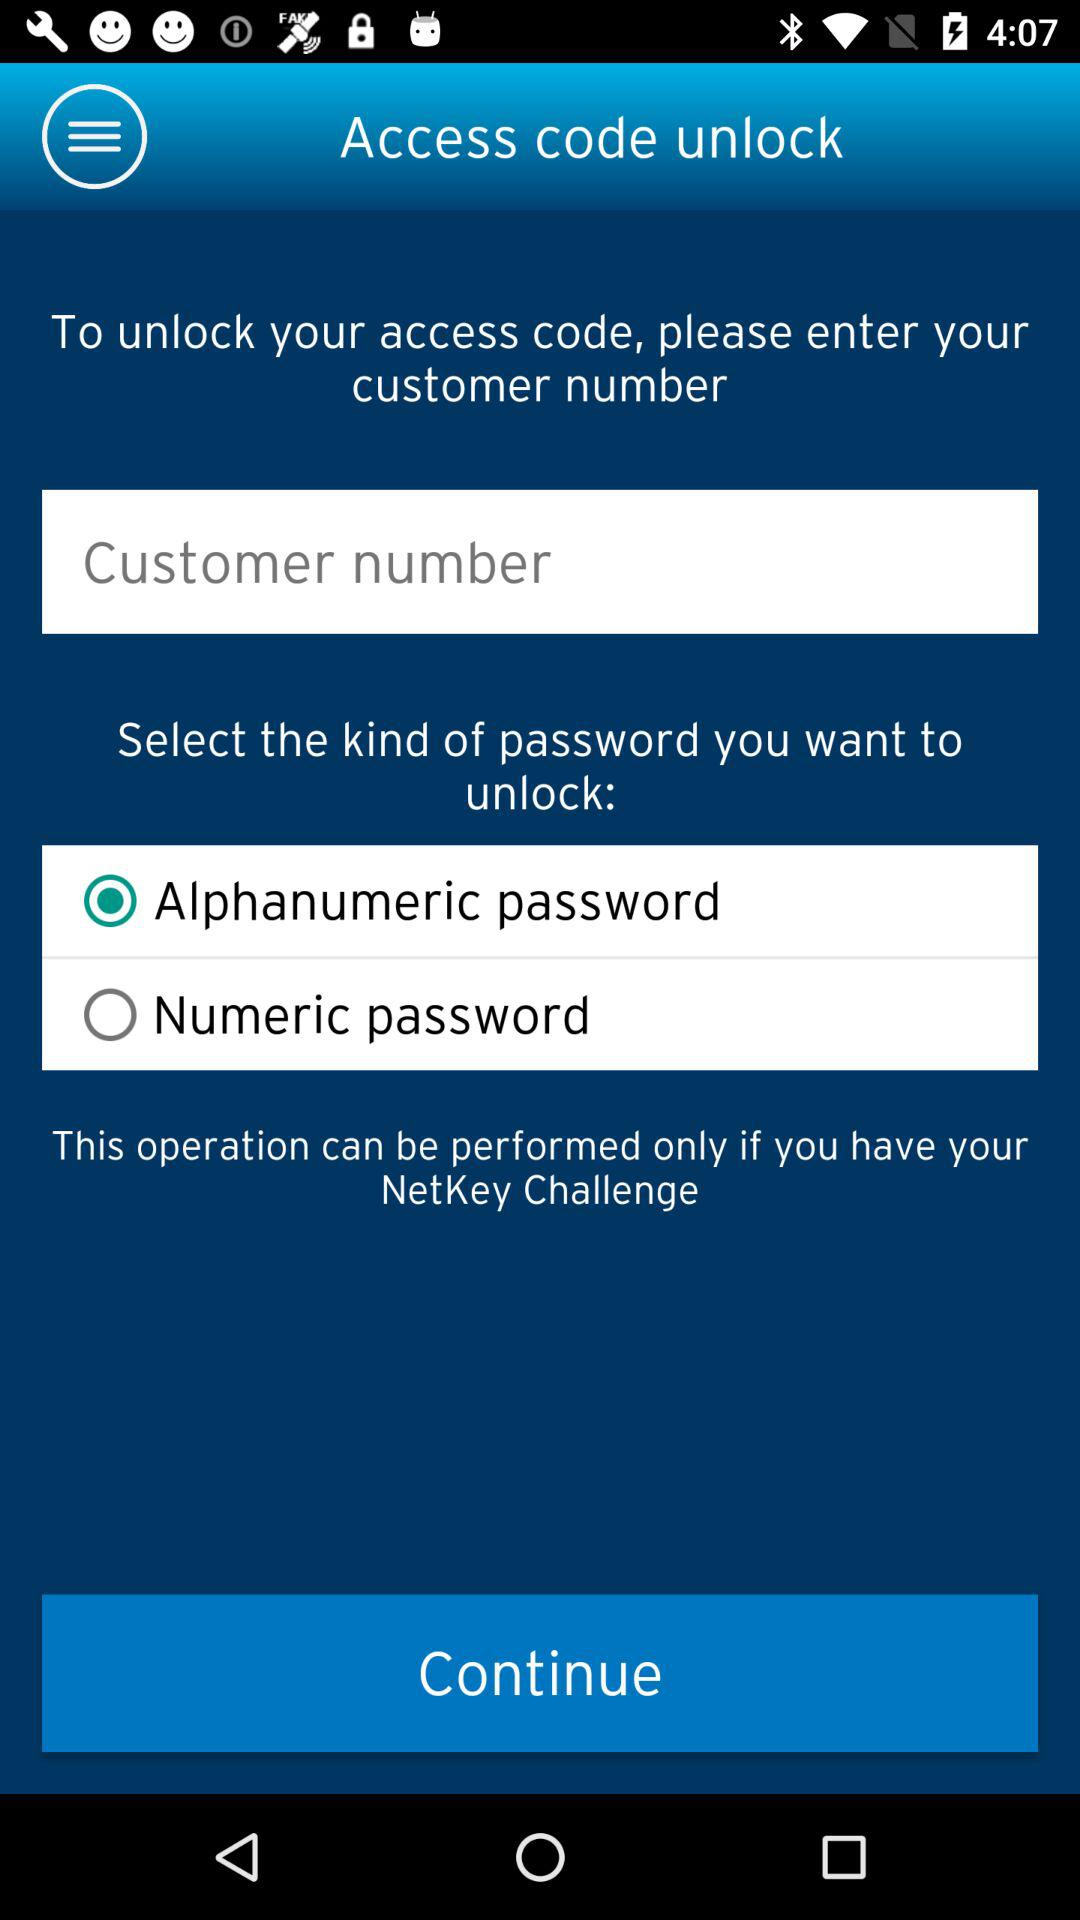What option has been selected? The selected option is "Alphanumeric password". 